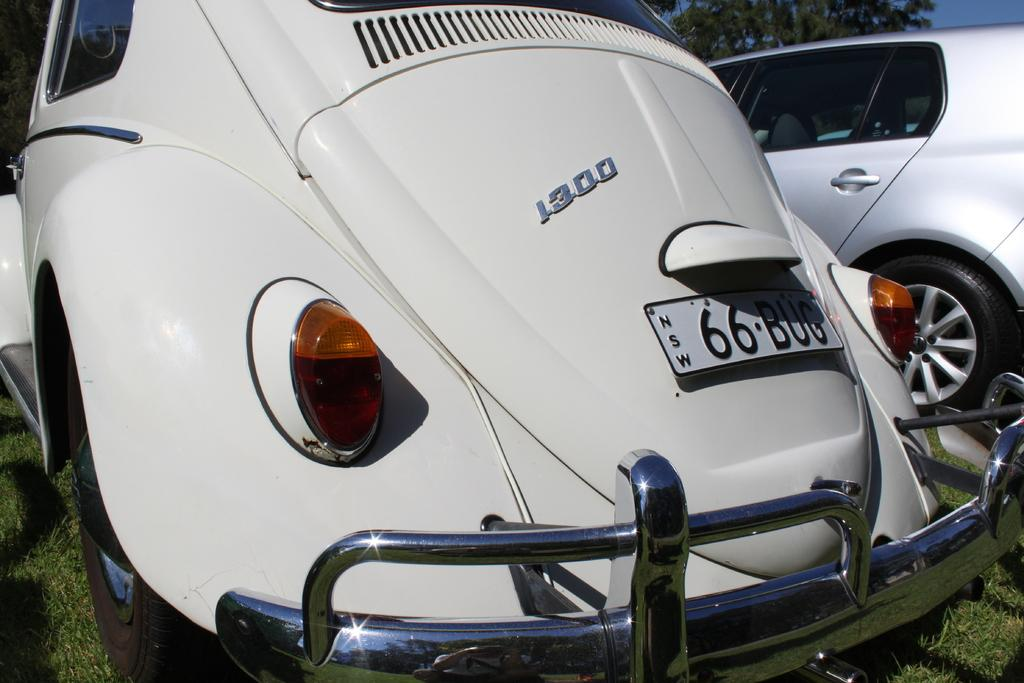How many vehicles can be seen in the image? There are two vehicles in the image. Where are the vehicles located? The vehicles are parked on the grass. What can be seen in the background of the image? There are trees and the sky visible in the background of the image. What type of bait is being used by the vehicles in the image? There is no bait present in the image, as the vehicles are parked on the grass and not engaged in any fishing activity. 